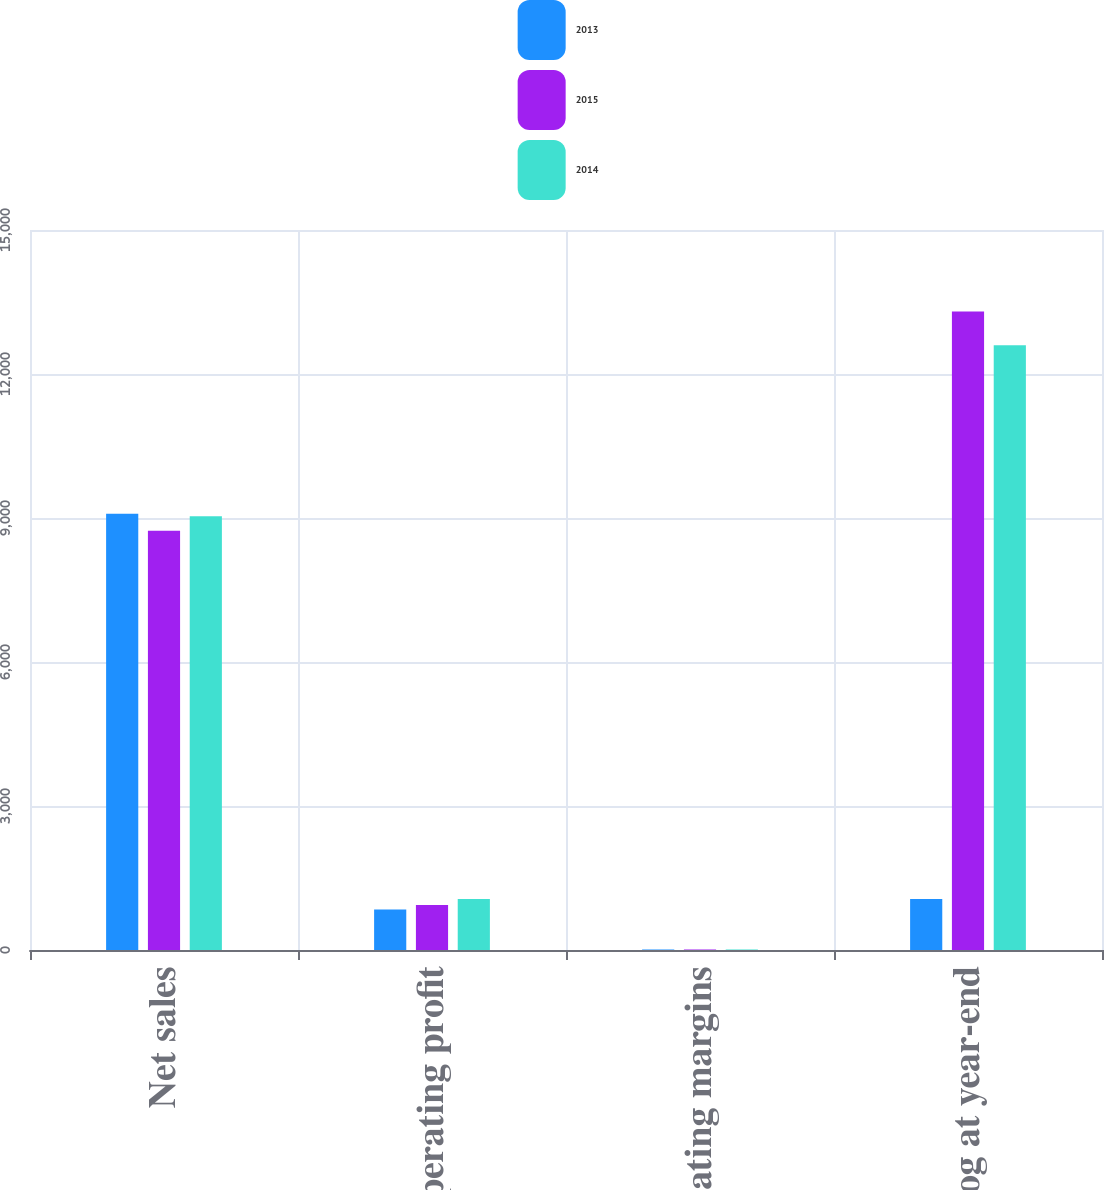Convert chart to OTSL. <chart><loc_0><loc_0><loc_500><loc_500><stacked_bar_chart><ecel><fcel>Net sales<fcel>Operating profit<fcel>Operating margins<fcel>Backlog at year-end<nl><fcel>2013<fcel>9091<fcel>844<fcel>9.3<fcel>1065<nl><fcel>2015<fcel>8732<fcel>936<fcel>10.7<fcel>13300<nl><fcel>2014<fcel>9037<fcel>1065<fcel>11.8<fcel>12600<nl></chart> 